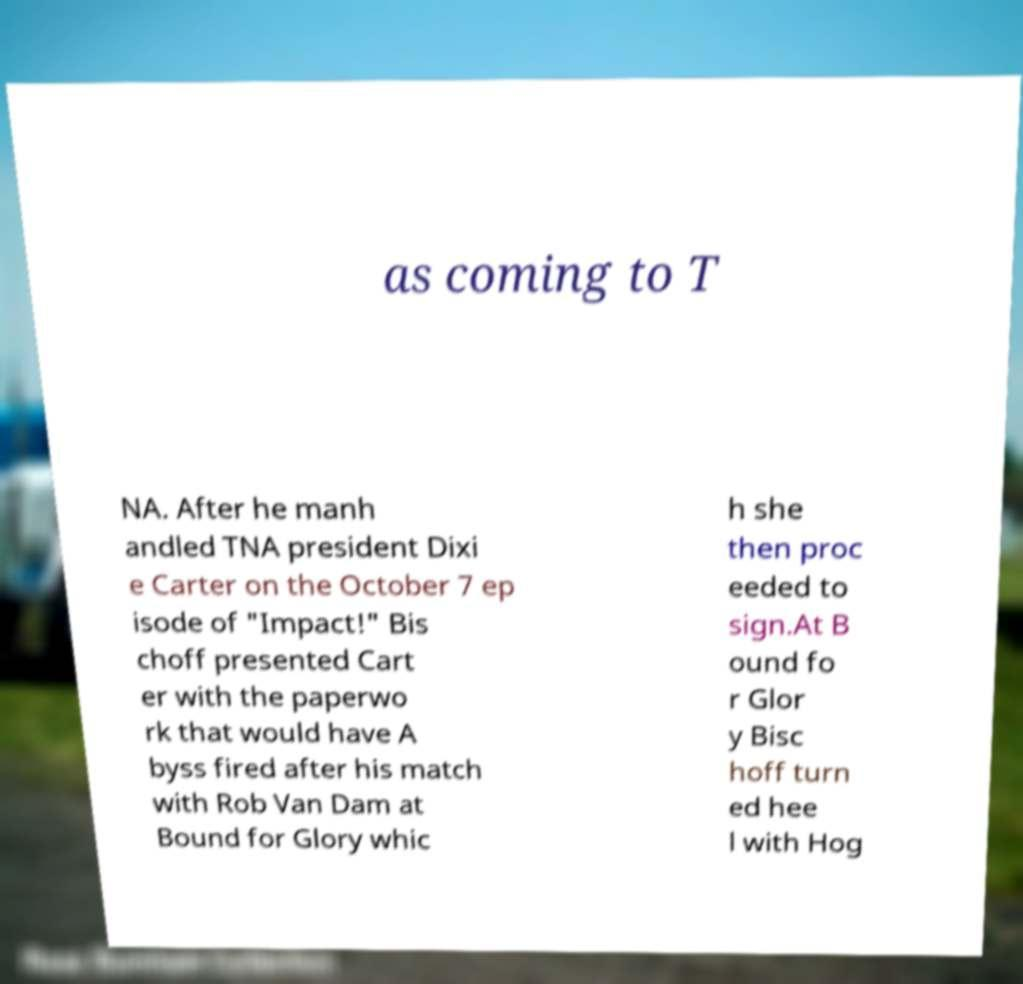What messages or text are displayed in this image? I need them in a readable, typed format. as coming to T NA. After he manh andled TNA president Dixi e Carter on the October 7 ep isode of "Impact!" Bis choff presented Cart er with the paperwo rk that would have A byss fired after his match with Rob Van Dam at Bound for Glory whic h she then proc eeded to sign.At B ound fo r Glor y Bisc hoff turn ed hee l with Hog 